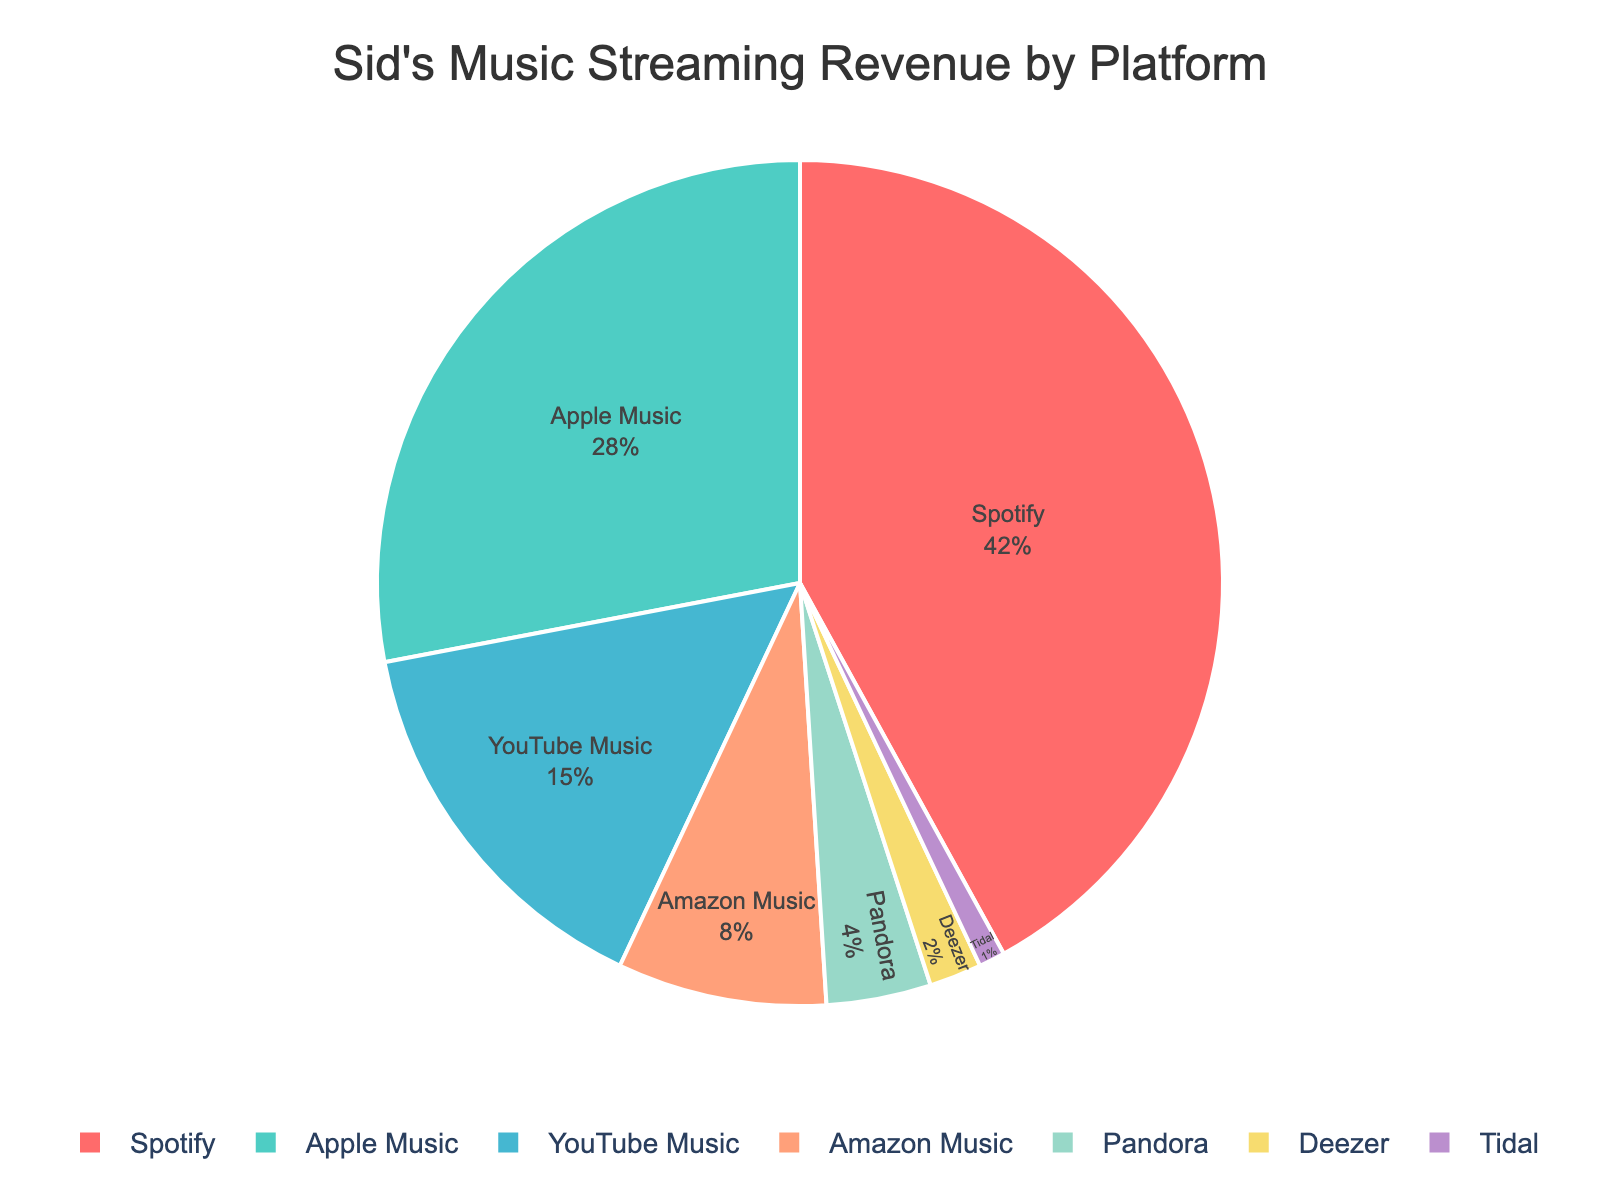What percentage of Sid's streaming revenue comes from Spotify and YouTube Music combined? To find the combined percentage of Spotify and YouTube Music, add their individual percentages. Spotify is 42% and YouTube Music is 15%. \( 42 + 15 = 57 \)
Answer: 57% Which platform contributes less to Sid's revenue, Deezer or Pandora? Compare the percentages of Deezer and Pandora. Deezer contributes 2%, while Pandora contributes 4%. Since 2% is less than 4%, Deezer contributes less.
Answer: Deezer What is the difference in revenue percentage between Apple Music and Amazon Music? To find the difference between Apple Music and Amazon Music, subtract the smaller percentage from the larger one. Apple Music is 28% and Amazon Music is 8%. \( 28 - 8 = 20 \)
Answer: 20% If Sid wanted to focus on the two platforms that contribute the least revenue, which platforms would they be? Identify the two platforms with the smallest percentages. Deezer has 2% and Tidal has 1%, making them the two smallest contributors.
Answer: Deezer and Tidal Does Amazon Music contribute more to Sid's revenue than YouTube Music? Compare the percentages of Amazon Music and YouTube Music. Amazon Music is 8%, while YouTube Music is 15%. Since 8% is less than 15%, Amazon Music contributes less.
Answer: No What is the total percentage of revenue coming from Pandora, Deezer, and Tidal combined? Add the percentages of Pandora, Deezer, and Tidal. Pandora is 4%, Deezer is 2%, and Tidal is 1%. \( 4 + 2 + 1 = 7 \)
Answer: 7% Based on the visual, which platform contributes the most to Sid's revenue? Identify the platform with the largest percentage slice in the pie chart. Spotify has the largest percentage at 42%.
Answer: Spotify How much more revenue percentage does Spotify contribute compared to the sum of Deezer and Tidal? First, sum the percentages of Deezer and Tidal, which are 2% and 1%, respectively. \( 2 + 1 = 3 \). Then, find the difference between Spotify's 42% and this sum. \( 42 - 3 = 39 \)
Answer: 39% What's the combined revenue percentage for the top three contributing platforms? Identify the top three platforms: Spotify (42%), Apple Music (28%), and YouTube Music (15%). Sum these percentages. \( 42 + 28 + 15 = 85 \)
Answer: 85% Which slice in the pie chart is represented by the color green, and what is its percentage? Based on the custom color palette used in the code, the second color is green. Identify the second platform by percentage, which is Apple Music at 28%.
Answer: Apple Music, 28% 